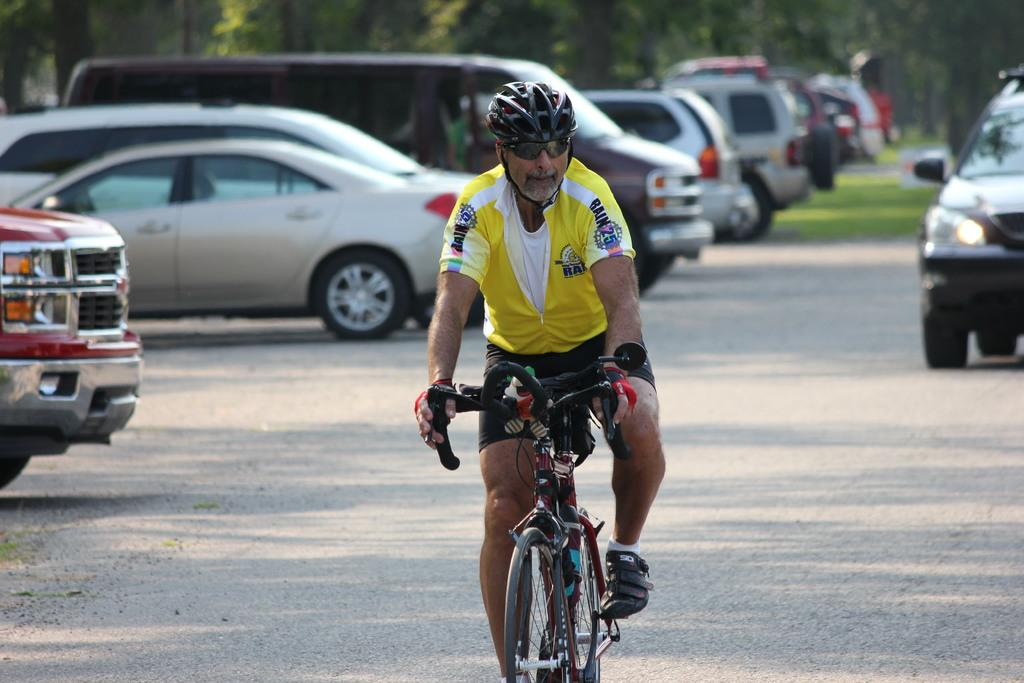Who is the main subject in the image? There is a man in the image. What is the man doing in the image? The man is riding a bicycle. Where is the bicycle located in the image? The bicycle is on the road. What else can be seen on the road in the image? Cars are parked on the road in the image. What type of patch is the man wearing on his bicycle in the image? There is no mention of a patch in the image, and the man is not wearing one on his bicycle. 